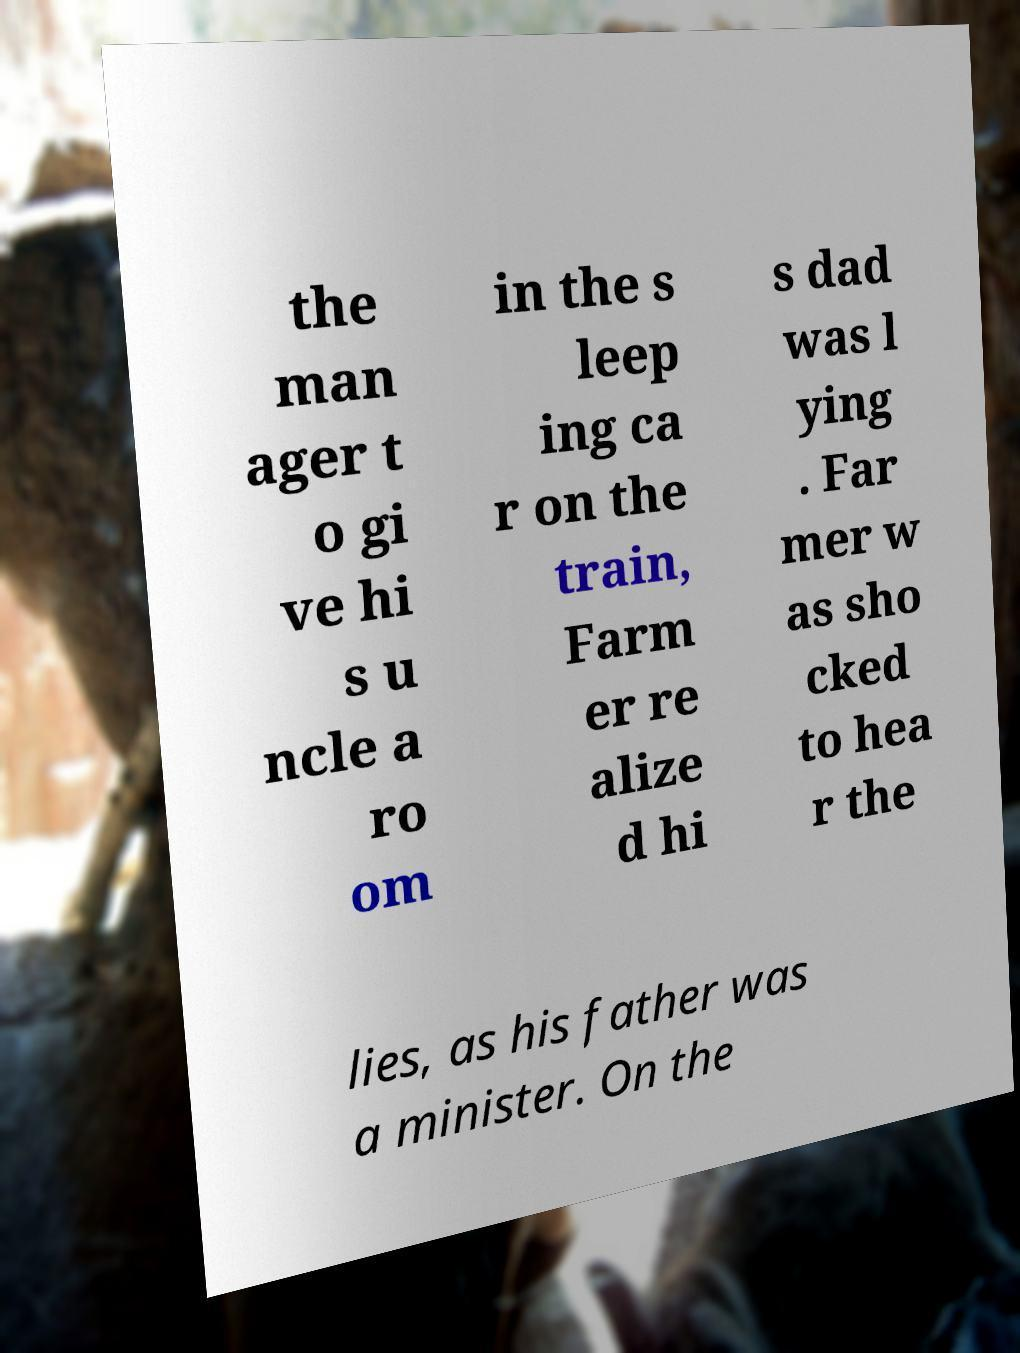What messages or text are displayed in this image? I need them in a readable, typed format. the man ager t o gi ve hi s u ncle a ro om in the s leep ing ca r on the train, Farm er re alize d hi s dad was l ying . Far mer w as sho cked to hea r the lies, as his father was a minister. On the 